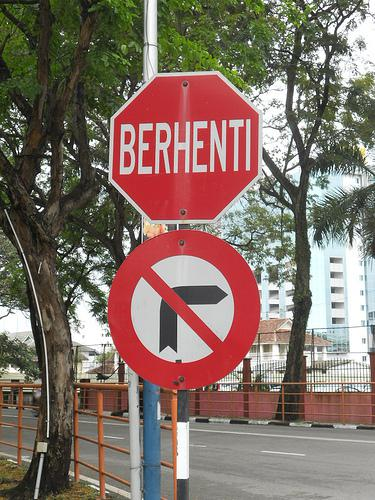Question: what is the meaning of this sign?
Choices:
A. Stop.
B. No left turn.
C. One way.
D. No right entry.
Answer with the letter. Answer: D Question: what is the color of road?
Choices:
A. White.
B. Yellow.
C. Light grey.
D. Black.
Answer with the letter. Answer: D Question: what is the color of the line drawn in the middle of the road?
Choices:
A. Yellow.
B. Black.
C. Green.
D. White.
Answer with the letter. Answer: D Question: how the sign is placed in the rod?
Choices:
A. With tape.
B. With magnets.
C. It was welded.
D. Through screws.
Answer with the letter. Answer: D 